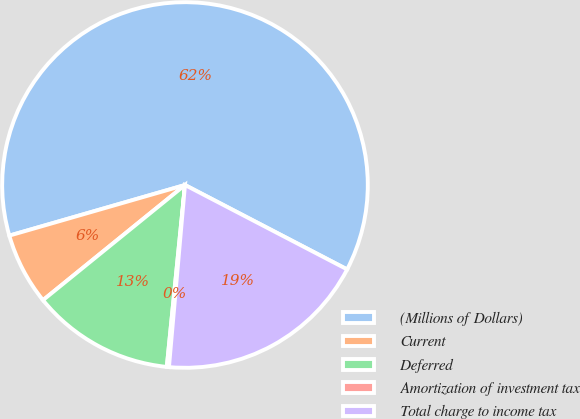Convert chart to OTSL. <chart><loc_0><loc_0><loc_500><loc_500><pie_chart><fcel>(Millions of Dollars)<fcel>Current<fcel>Deferred<fcel>Amortization of investment tax<fcel>Total charge to income tax<nl><fcel>62.11%<fcel>6.38%<fcel>12.57%<fcel>0.19%<fcel>18.76%<nl></chart> 